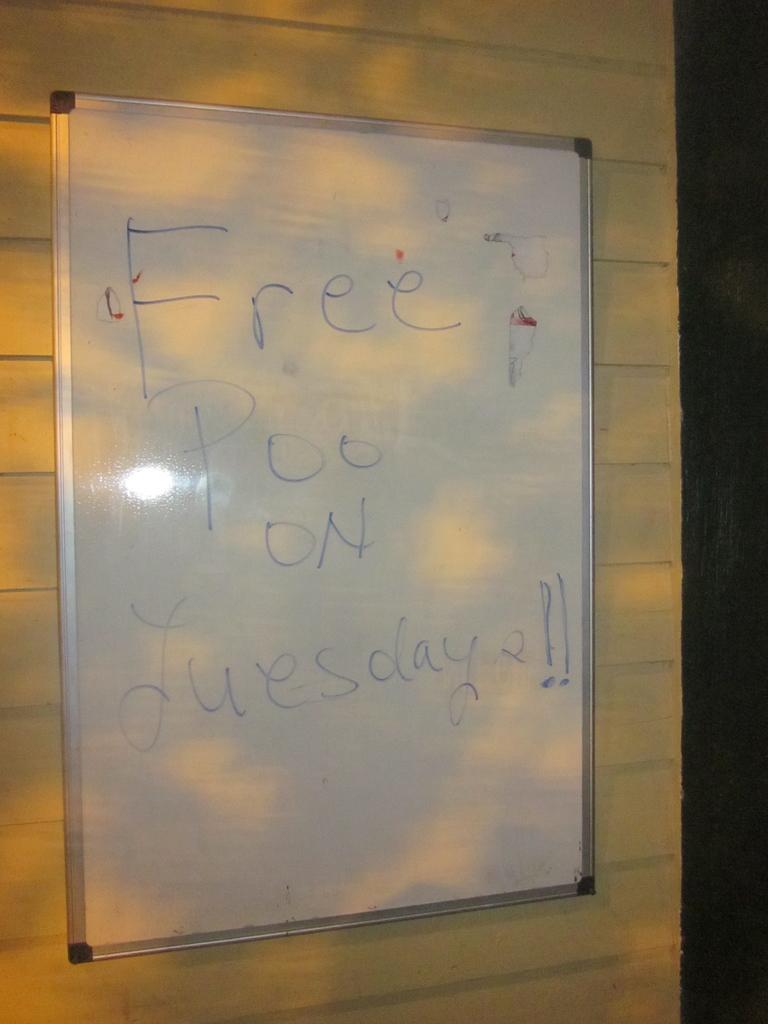What is free on tuesday?
Offer a very short reply. Poo. What color is the marker used?
Ensure brevity in your answer.  Blue. 